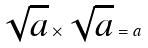<formula> <loc_0><loc_0><loc_500><loc_500>\sqrt { a } \times \sqrt { a } = a</formula> 